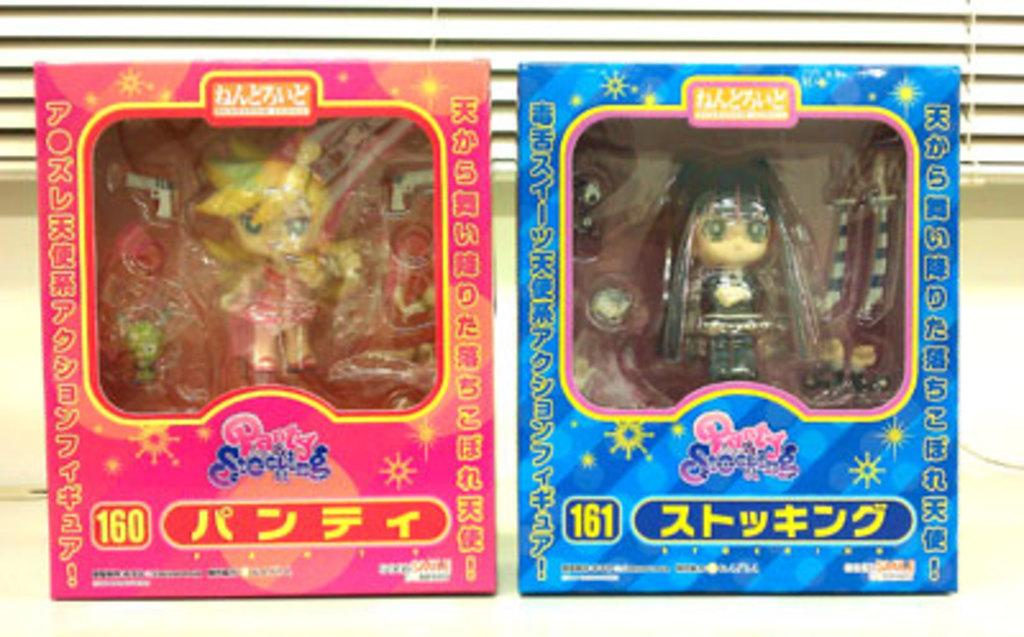How many toy boxes are visible in the image? There are two toy boxes in the image. Where are the toy boxes located in relation to each other? The toy boxes are beside each other. What can be found inside the toy boxes? There are small toys in the toy boxes. What can be seen in the background of the image? There is a curtain in the background of the image. What type of bomb is hidden behind the curtain in the image? There is no bomb present in the image; it is a scene with toy boxes and a curtain in the background. 